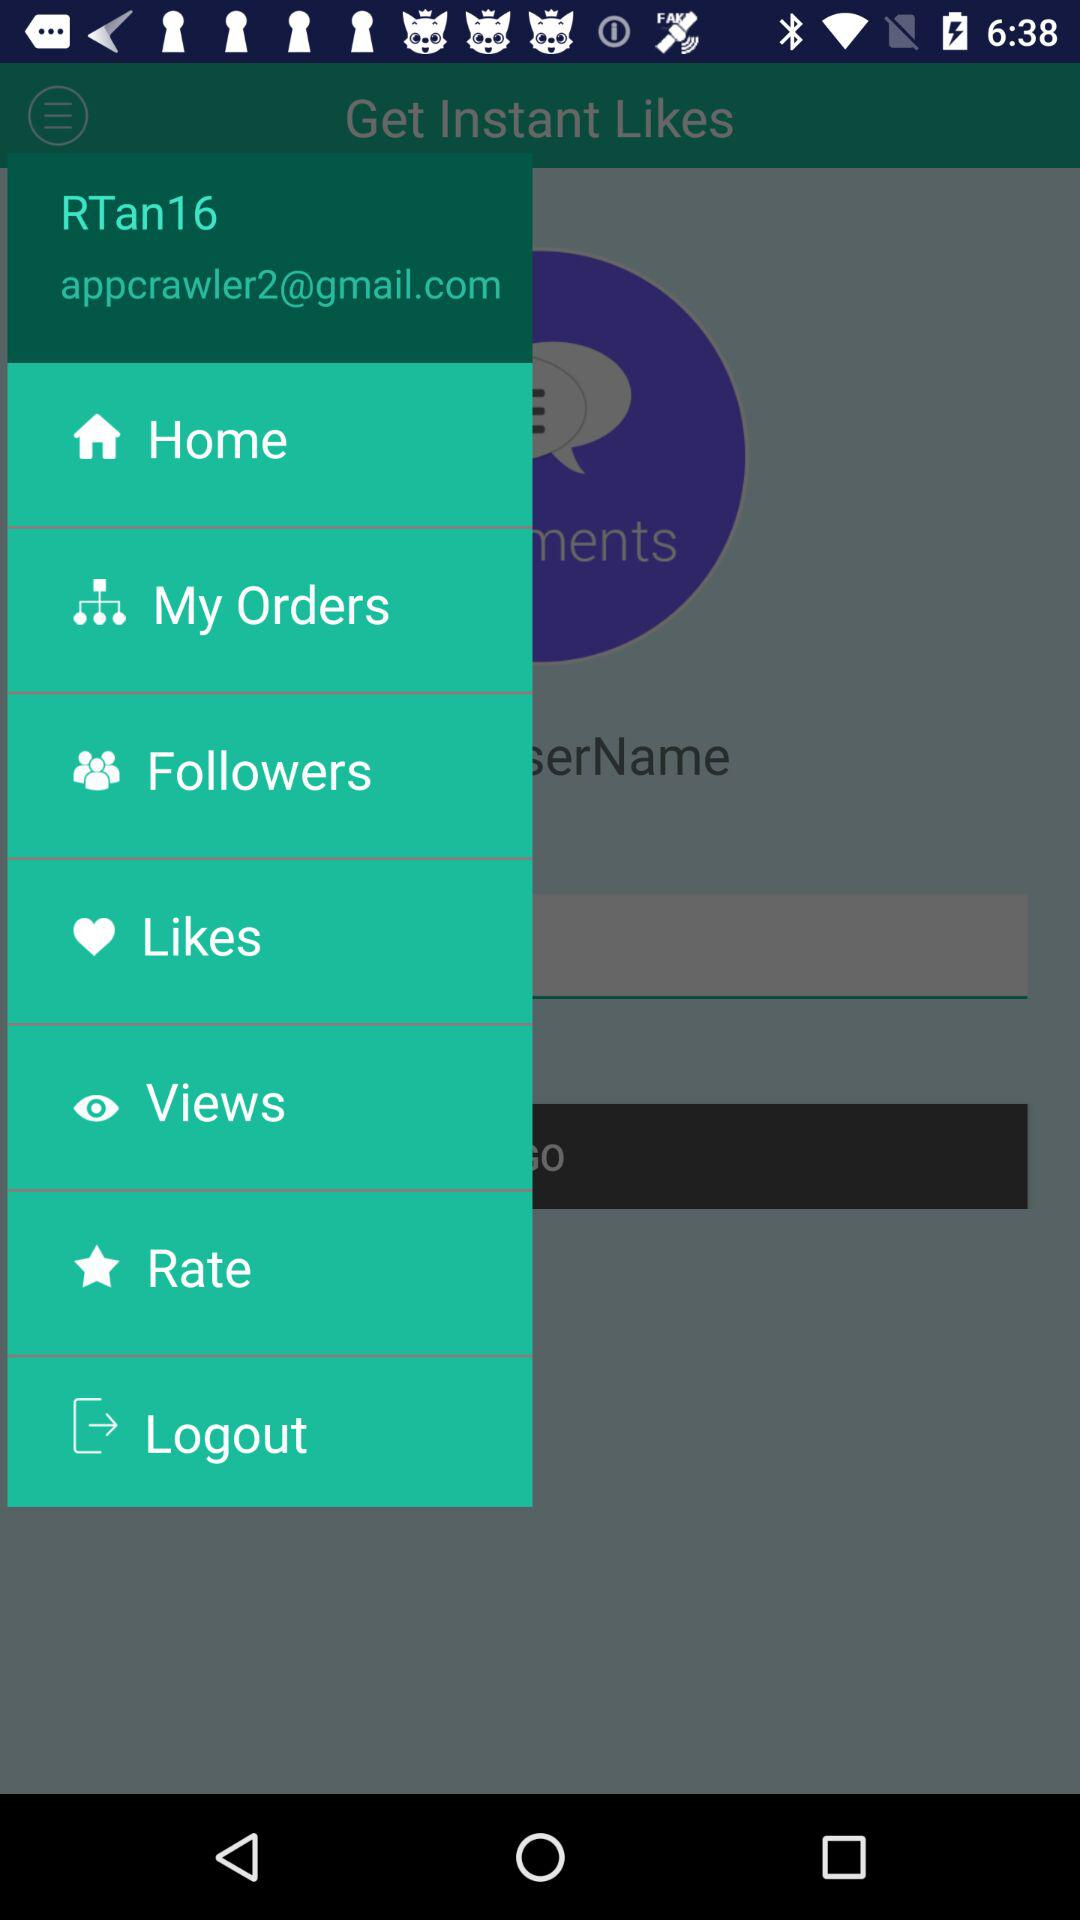What is the email address of the user? The email address of the user is appcrawler2@gmail.com. 